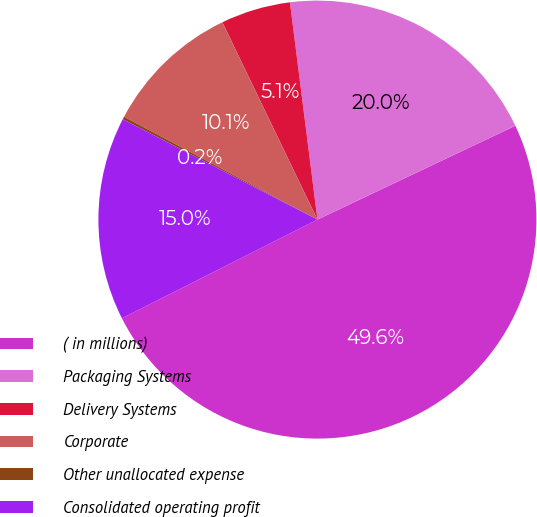<chart> <loc_0><loc_0><loc_500><loc_500><pie_chart><fcel>( in millions)<fcel>Packaging Systems<fcel>Delivery Systems<fcel>Corporate<fcel>Other unallocated expense<fcel>Consolidated operating profit<nl><fcel>49.61%<fcel>19.96%<fcel>5.14%<fcel>10.08%<fcel>0.2%<fcel>15.02%<nl></chart> 